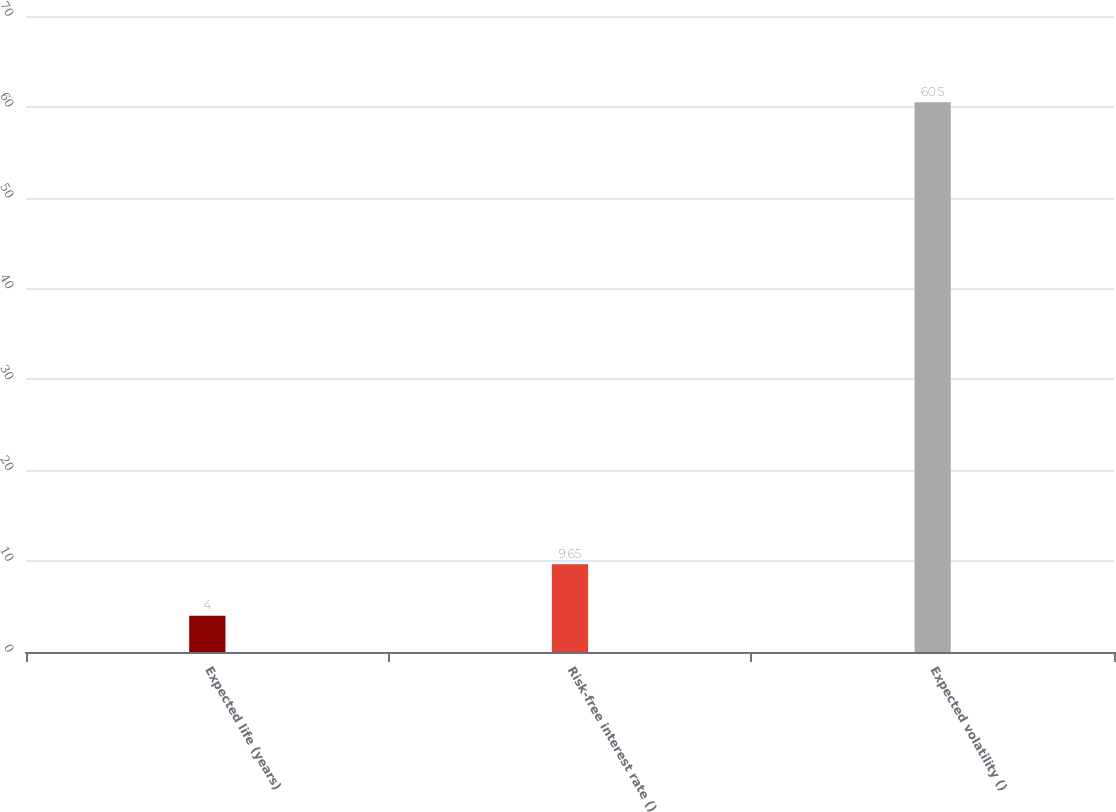Convert chart to OTSL. <chart><loc_0><loc_0><loc_500><loc_500><bar_chart><fcel>Expected life (years)<fcel>Risk-free interest rate ()<fcel>Expected volatility ()<nl><fcel>4<fcel>9.65<fcel>60.5<nl></chart> 